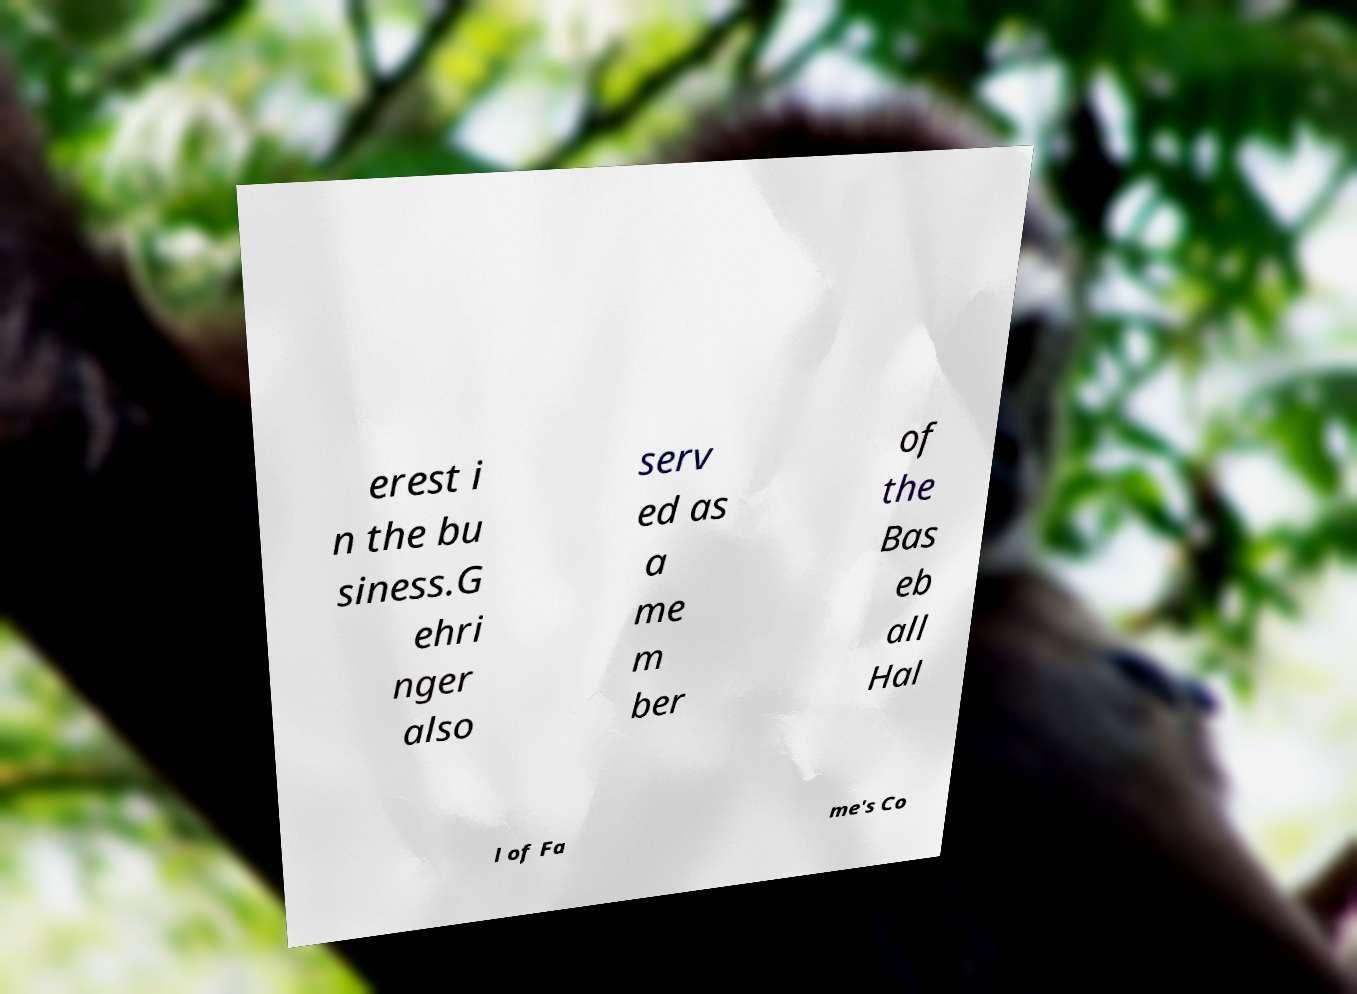Please read and relay the text visible in this image. What does it say? erest i n the bu siness.G ehri nger also serv ed as a me m ber of the Bas eb all Hal l of Fa me's Co 